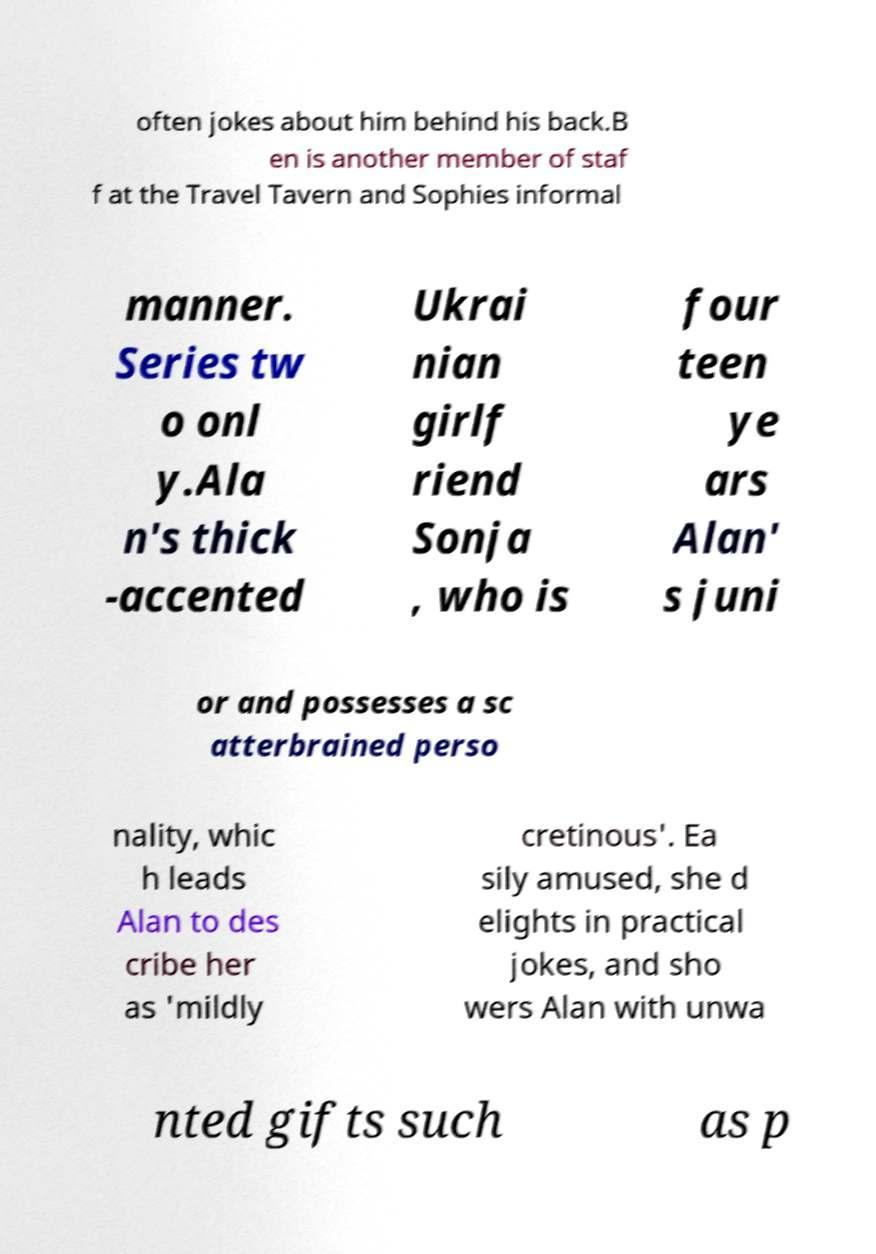Please read and relay the text visible in this image. What does it say? often jokes about him behind his back.B en is another member of staf f at the Travel Tavern and Sophies informal manner. Series tw o onl y.Ala n's thick -accented Ukrai nian girlf riend Sonja , who is four teen ye ars Alan' s juni or and possesses a sc atterbrained perso nality, whic h leads Alan to des cribe her as 'mildly cretinous'. Ea sily amused, she d elights in practical jokes, and sho wers Alan with unwa nted gifts such as p 